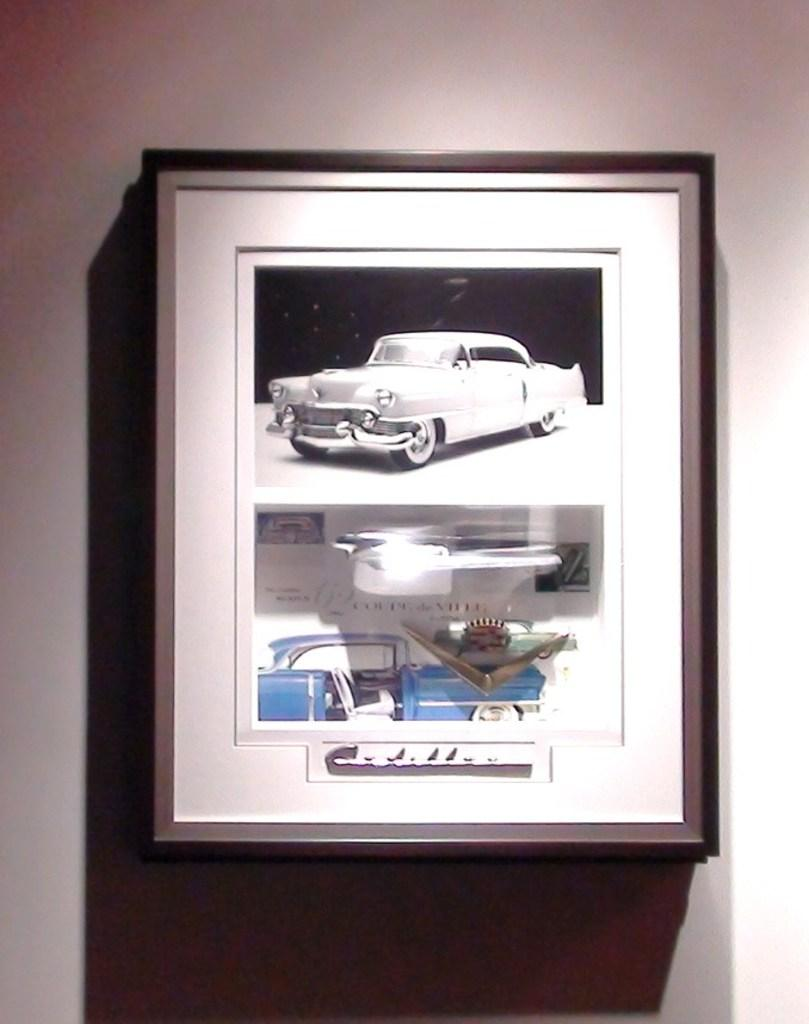What is hanging on the wall in the image? There is a photo frame on the wall in the image. What is depicted in the photo frame? The photo frame contains a picture of cars. How many dogs are visible in the image? There are no dogs present in the image; it features a photo frame with a picture of cars. What type of truck can be seen driving on the earth in the image? There is no truck or earth visible in the image; it only contains a photo frame with a picture of cars. 